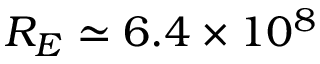Convert formula to latex. <formula><loc_0><loc_0><loc_500><loc_500>R _ { E } \simeq 6 . 4 \times 1 0 ^ { 8 }</formula> 